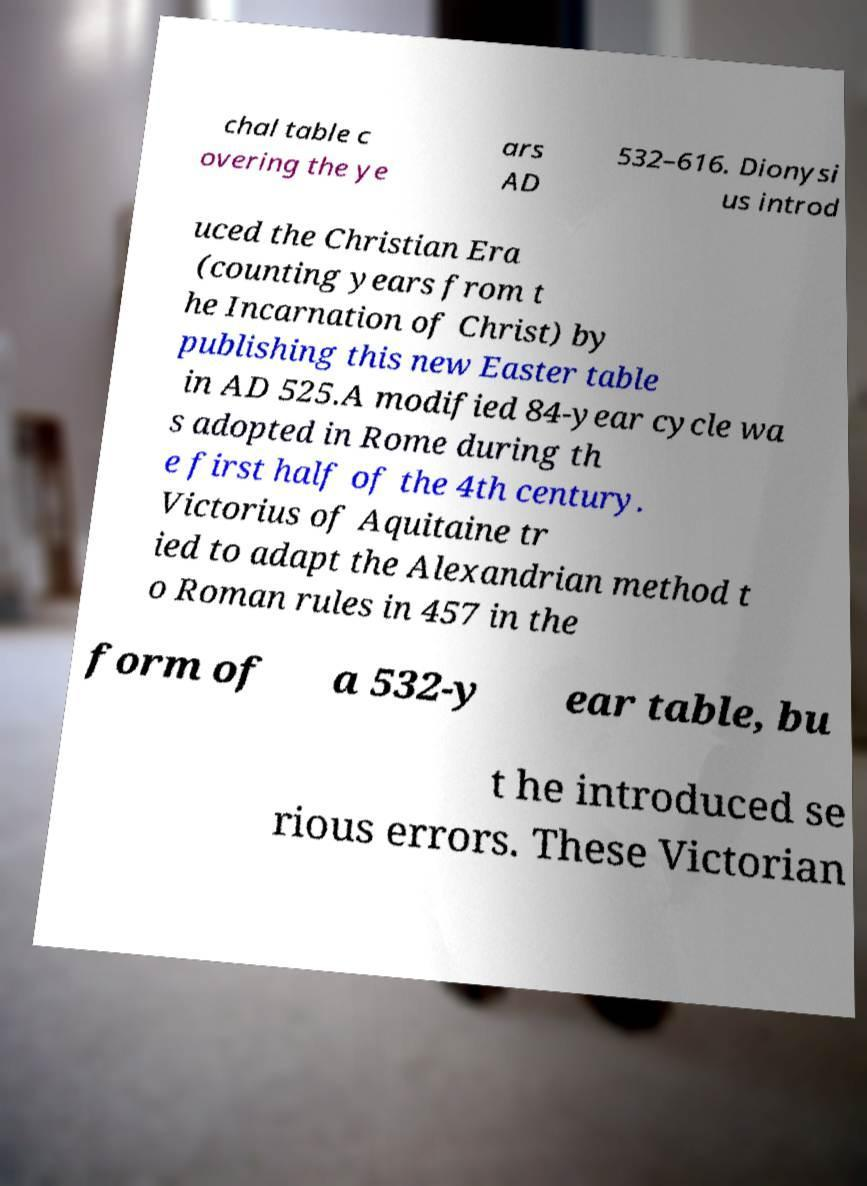For documentation purposes, I need the text within this image transcribed. Could you provide that? chal table c overing the ye ars AD 532–616. Dionysi us introd uced the Christian Era (counting years from t he Incarnation of Christ) by publishing this new Easter table in AD 525.A modified 84-year cycle wa s adopted in Rome during th e first half of the 4th century. Victorius of Aquitaine tr ied to adapt the Alexandrian method t o Roman rules in 457 in the form of a 532-y ear table, bu t he introduced se rious errors. These Victorian 